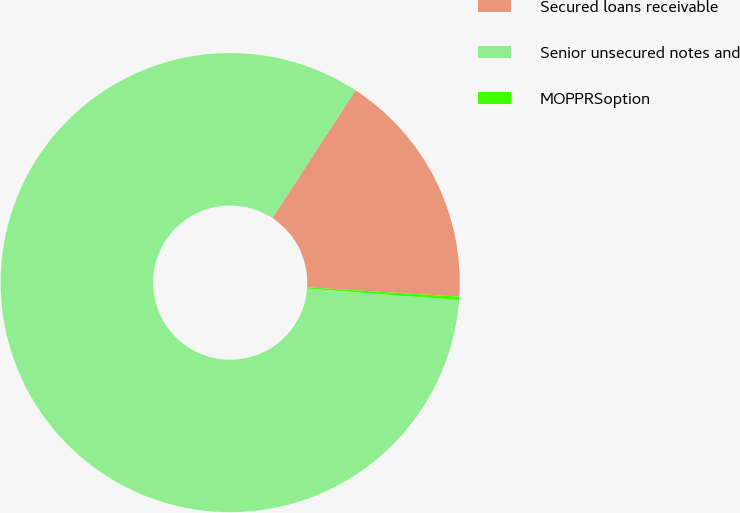Convert chart to OTSL. <chart><loc_0><loc_0><loc_500><loc_500><pie_chart><fcel>Secured loans receivable<fcel>Senior unsecured notes and<fcel>MOPPRSoption<nl><fcel>16.78%<fcel>82.97%<fcel>0.24%<nl></chart> 